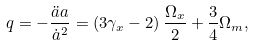<formula> <loc_0><loc_0><loc_500><loc_500>q = - \frac { \ddot { a } a } { \dot { a } ^ { 2 } } = \left ( 3 \gamma _ { x } - 2 \right ) \frac { \Omega _ { x } } { 2 } + \frac { 3 } { 4 } \Omega _ { m } ,</formula> 